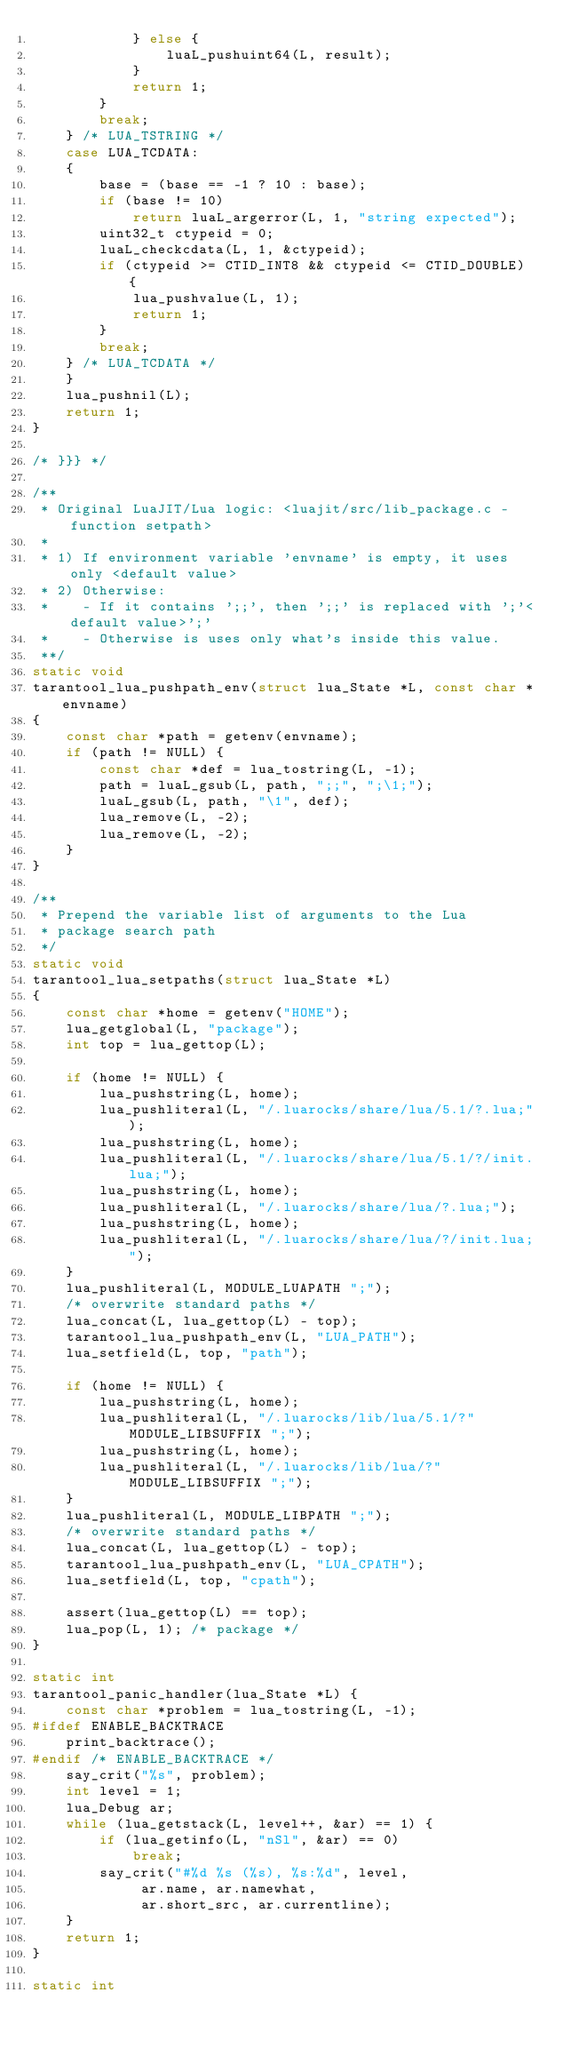<code> <loc_0><loc_0><loc_500><loc_500><_C_>			} else {
				luaL_pushuint64(L, result);
			}
			return 1;
		}
		break;
	} /* LUA_TSTRING */
	case LUA_TCDATA:
	{
		base = (base == -1 ? 10 : base);
		if (base != 10)
			return luaL_argerror(L, 1, "string expected");
		uint32_t ctypeid = 0;
		luaL_checkcdata(L, 1, &ctypeid);
		if (ctypeid >= CTID_INT8 && ctypeid <= CTID_DOUBLE) {
			lua_pushvalue(L, 1);
			return 1;
		}
		break;
	} /* LUA_TCDATA */
	}
	lua_pushnil(L);
	return 1;
}

/* }}} */

/**
 * Original LuaJIT/Lua logic: <luajit/src/lib_package.c - function setpath>
 *
 * 1) If environment variable 'envname' is empty, it uses only <default value>
 * 2) Otherwise:
 *    - If it contains ';;', then ';;' is replaced with ';'<default value>';'
 *    - Otherwise is uses only what's inside this value.
 **/
static void
tarantool_lua_pushpath_env(struct lua_State *L, const char *envname)
{
	const char *path = getenv(envname);
	if (path != NULL) {
		const char *def = lua_tostring(L, -1);
		path = luaL_gsub(L, path, ";;", ";\1;");
		luaL_gsub(L, path, "\1", def);
		lua_remove(L, -2);
		lua_remove(L, -2);
	}
}

/**
 * Prepend the variable list of arguments to the Lua
 * package search path
 */
static void
tarantool_lua_setpaths(struct lua_State *L)
{
	const char *home = getenv("HOME");
	lua_getglobal(L, "package");
	int top = lua_gettop(L);

	if (home != NULL) {
		lua_pushstring(L, home);
		lua_pushliteral(L, "/.luarocks/share/lua/5.1/?.lua;");
		lua_pushstring(L, home);
		lua_pushliteral(L, "/.luarocks/share/lua/5.1/?/init.lua;");
		lua_pushstring(L, home);
		lua_pushliteral(L, "/.luarocks/share/lua/?.lua;");
		lua_pushstring(L, home);
		lua_pushliteral(L, "/.luarocks/share/lua/?/init.lua;");
	}
	lua_pushliteral(L, MODULE_LUAPATH ";");
	/* overwrite standard paths */
	lua_concat(L, lua_gettop(L) - top);
	tarantool_lua_pushpath_env(L, "LUA_PATH");
	lua_setfield(L, top, "path");

	if (home != NULL) {
		lua_pushstring(L, home);
		lua_pushliteral(L, "/.luarocks/lib/lua/5.1/?" MODULE_LIBSUFFIX ";");
		lua_pushstring(L, home);
		lua_pushliteral(L, "/.luarocks/lib/lua/?" MODULE_LIBSUFFIX ";");
	}
	lua_pushliteral(L, MODULE_LIBPATH ";");
	/* overwrite standard paths */
	lua_concat(L, lua_gettop(L) - top);
	tarantool_lua_pushpath_env(L, "LUA_CPATH");
	lua_setfield(L, top, "cpath");

	assert(lua_gettop(L) == top);
	lua_pop(L, 1); /* package */
}

static int
tarantool_panic_handler(lua_State *L) {
	const char *problem = lua_tostring(L, -1);
#ifdef ENABLE_BACKTRACE
	print_backtrace();
#endif /* ENABLE_BACKTRACE */
	say_crit("%s", problem);
	int level = 1;
	lua_Debug ar;
	while (lua_getstack(L, level++, &ar) == 1) {
		if (lua_getinfo(L, "nSl", &ar) == 0)
			break;
		say_crit("#%d %s (%s), %s:%d", level,
			 ar.name, ar.namewhat,
			 ar.short_src, ar.currentline);
	}
	return 1;
}

static int</code> 